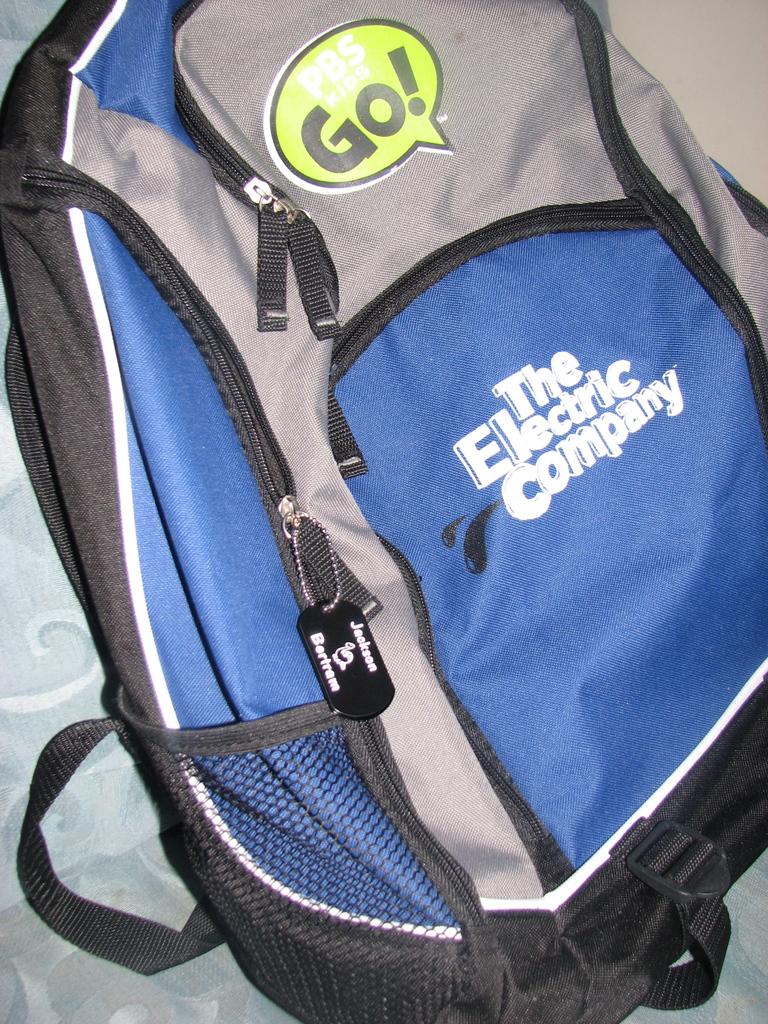What tv channel is referenced on this backpack?
Your answer should be compact. Pbs. Whats the name on the bookbag?
Your response must be concise. The electric company. 